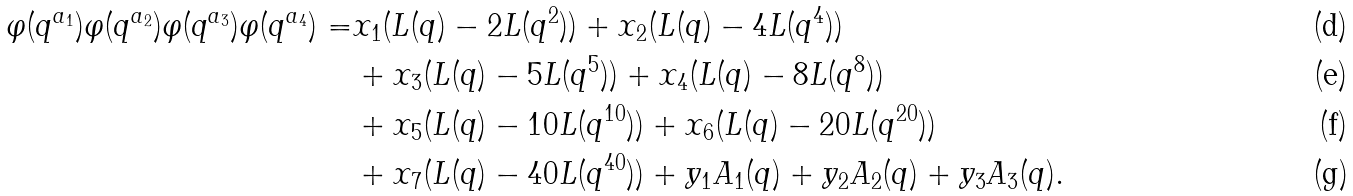Convert formula to latex. <formula><loc_0><loc_0><loc_500><loc_500>\varphi ( q ^ { a _ { 1 } } ) \varphi ( q ^ { a _ { 2 } } ) \varphi ( q ^ { a _ { 3 } } ) \varphi ( q ^ { a _ { 4 } } ) = & x _ { 1 } ( L ( q ) - 2 L ( q ^ { 2 } ) ) + x _ { 2 } ( L ( q ) - 4 L ( q ^ { 4 } ) ) \\ & + x _ { 3 } ( L ( q ) - 5 L ( q ^ { 5 } ) ) + x _ { 4 } ( L ( q ) - 8 L ( q ^ { 8 } ) ) \\ & + x _ { 5 } ( L ( q ) - 1 0 L ( q ^ { 1 0 } ) ) + x _ { 6 } ( L ( q ) - 2 0 L ( q ^ { 2 0 } ) ) \\ & + x _ { 7 } ( L ( q ) - 4 0 L ( q ^ { 4 0 } ) ) + y _ { 1 } A _ { 1 } ( q ) + y _ { 2 } A _ { 2 } ( q ) + y _ { 3 } A _ { 3 } ( q ) .</formula> 